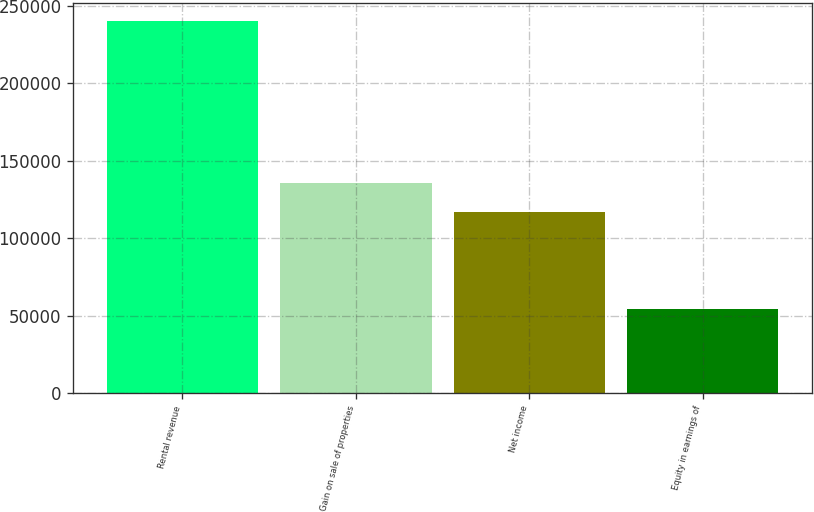Convert chart to OTSL. <chart><loc_0><loc_0><loc_500><loc_500><bar_chart><fcel>Rental revenue<fcel>Gain on sale of properties<fcel>Net income<fcel>Equity in earnings of<nl><fcel>240064<fcel>135427<fcel>116832<fcel>54116<nl></chart> 